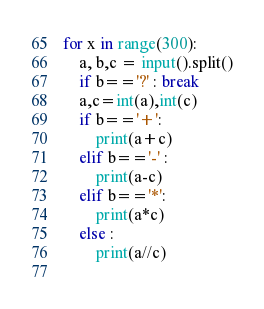<code> <loc_0><loc_0><loc_500><loc_500><_Python_>for x in range(300):
    a, b,c = input().split()
    if b=='?' : break
    a,c=int(a),int(c)
    if b=='+':
        print(a+c)
    elif b=='-' :
        print(a-c)
    elif b=='*':
        print(a*c)
    else :
        print(a//c)
    
</code> 